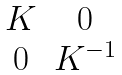<formula> <loc_0><loc_0><loc_500><loc_500>\begin{matrix} K & 0 \\ 0 & K ^ { - 1 } \end{matrix}</formula> 